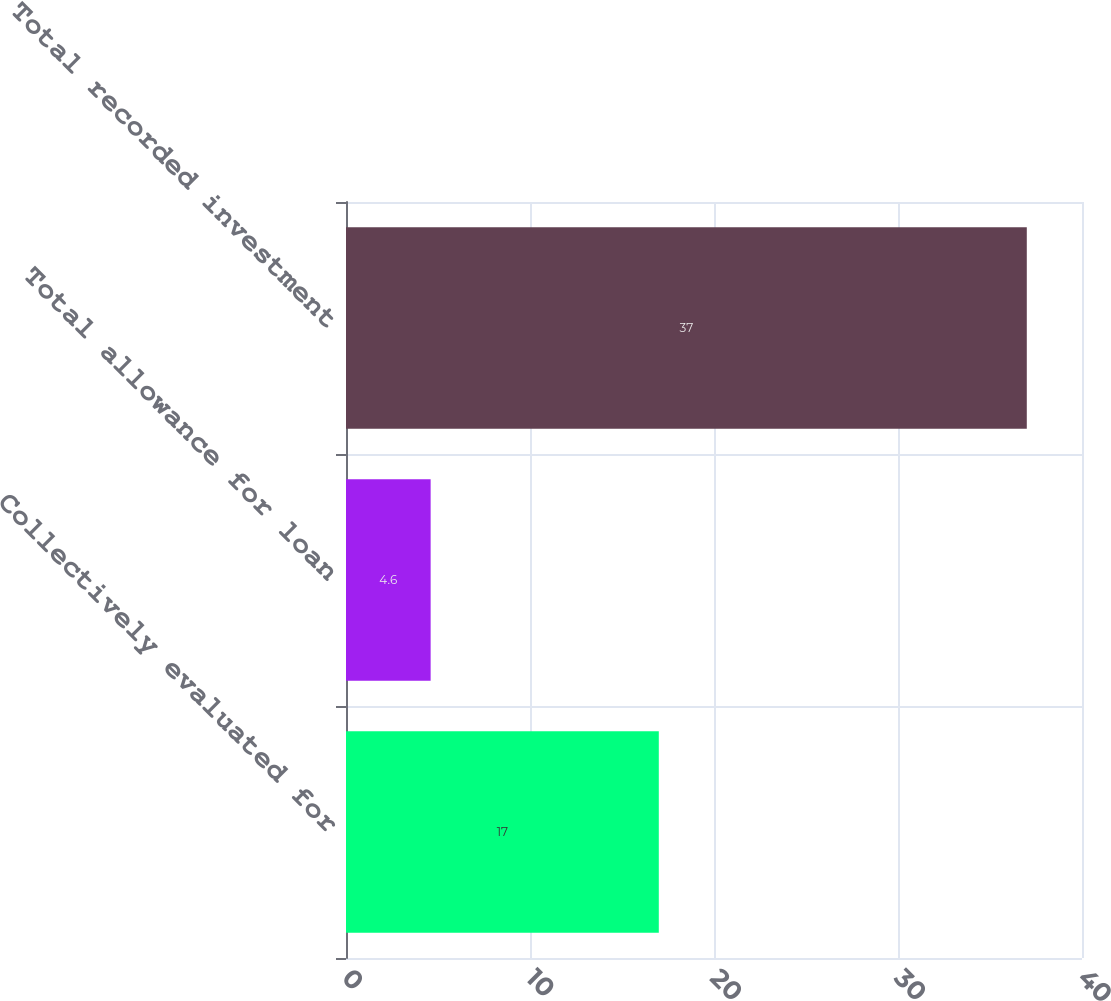Convert chart to OTSL. <chart><loc_0><loc_0><loc_500><loc_500><bar_chart><fcel>Collectively evaluated for<fcel>Total allowance for loan<fcel>Total recorded investment<nl><fcel>17<fcel>4.6<fcel>37<nl></chart> 